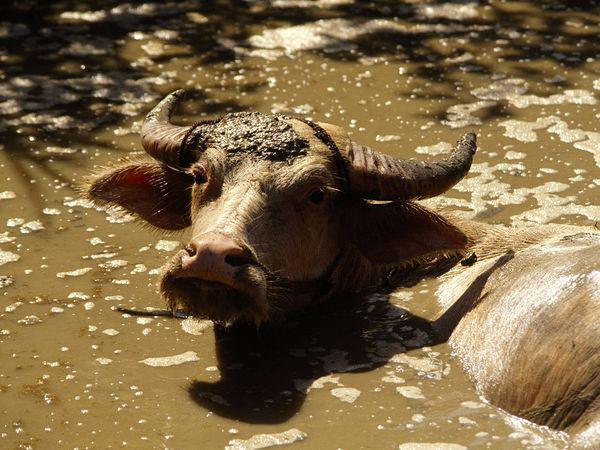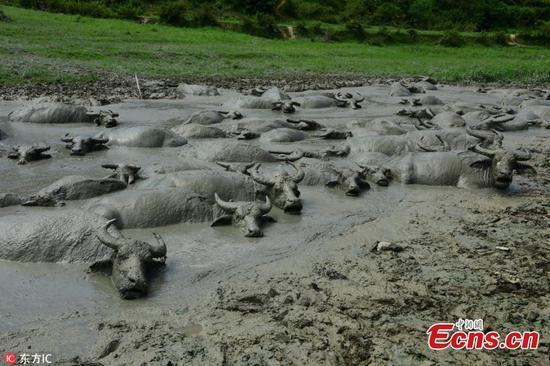The first image is the image on the left, the second image is the image on the right. Examine the images to the left and right. Is the description "The cow in each image is standing past their legs in the mud." accurate? Answer yes or no. Yes. The first image is the image on the left, the second image is the image on the right. For the images displayed, is the sentence "All water buffalo are in mud that reaches at least to their chest, and no image contains more than three water buffalo." factually correct? Answer yes or no. No. 